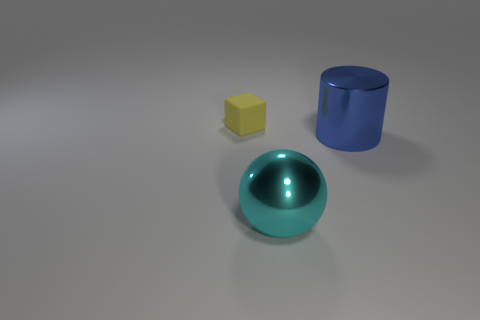What can the different colors of objects in this image signify in a learning context? In a learning context, the colors of the objects can be used to teach basic concepts of color theory, object recognition, and geometry. For example, the yellow cube can be used to discuss primary colors and shapes, while the blue cylinder could be explored in lessons about cylindrical volumes and the properties of secondary colors. 